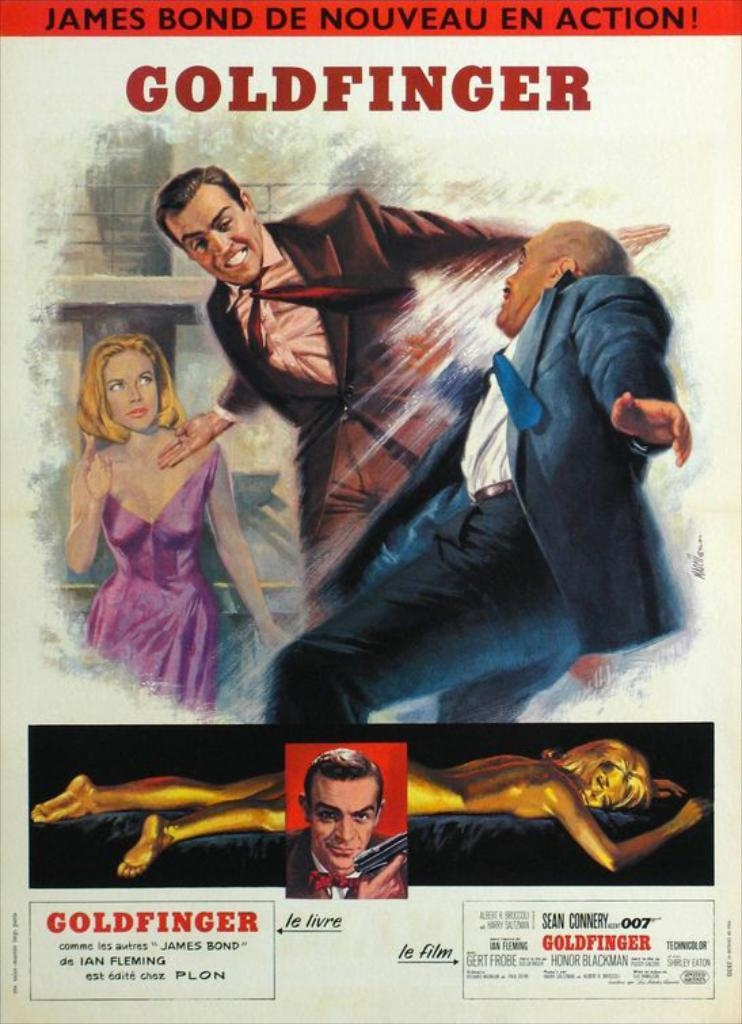<image>
Create a compact narrative representing the image presented. A movie poster advertising Goldfinger, James Bond de noveau en action. 